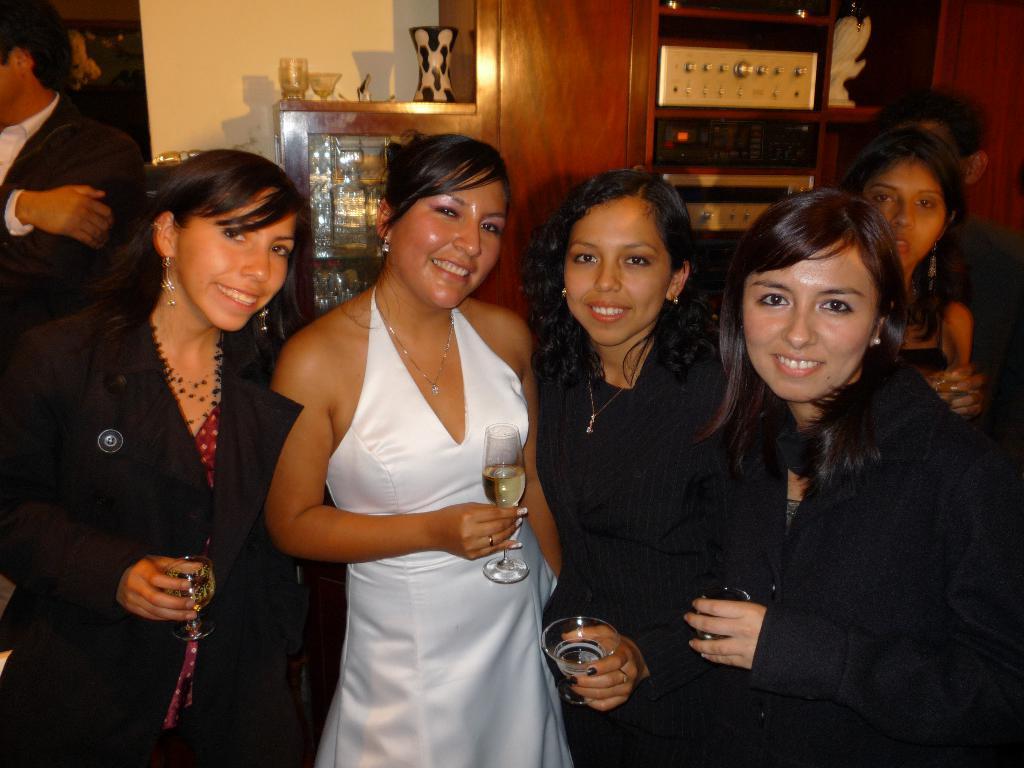How would you summarize this image in a sentence or two? In this picture we can see a group of people standing and few people holding the glasses. Behind the people, there is a wall and there are some objects in the shelves. 